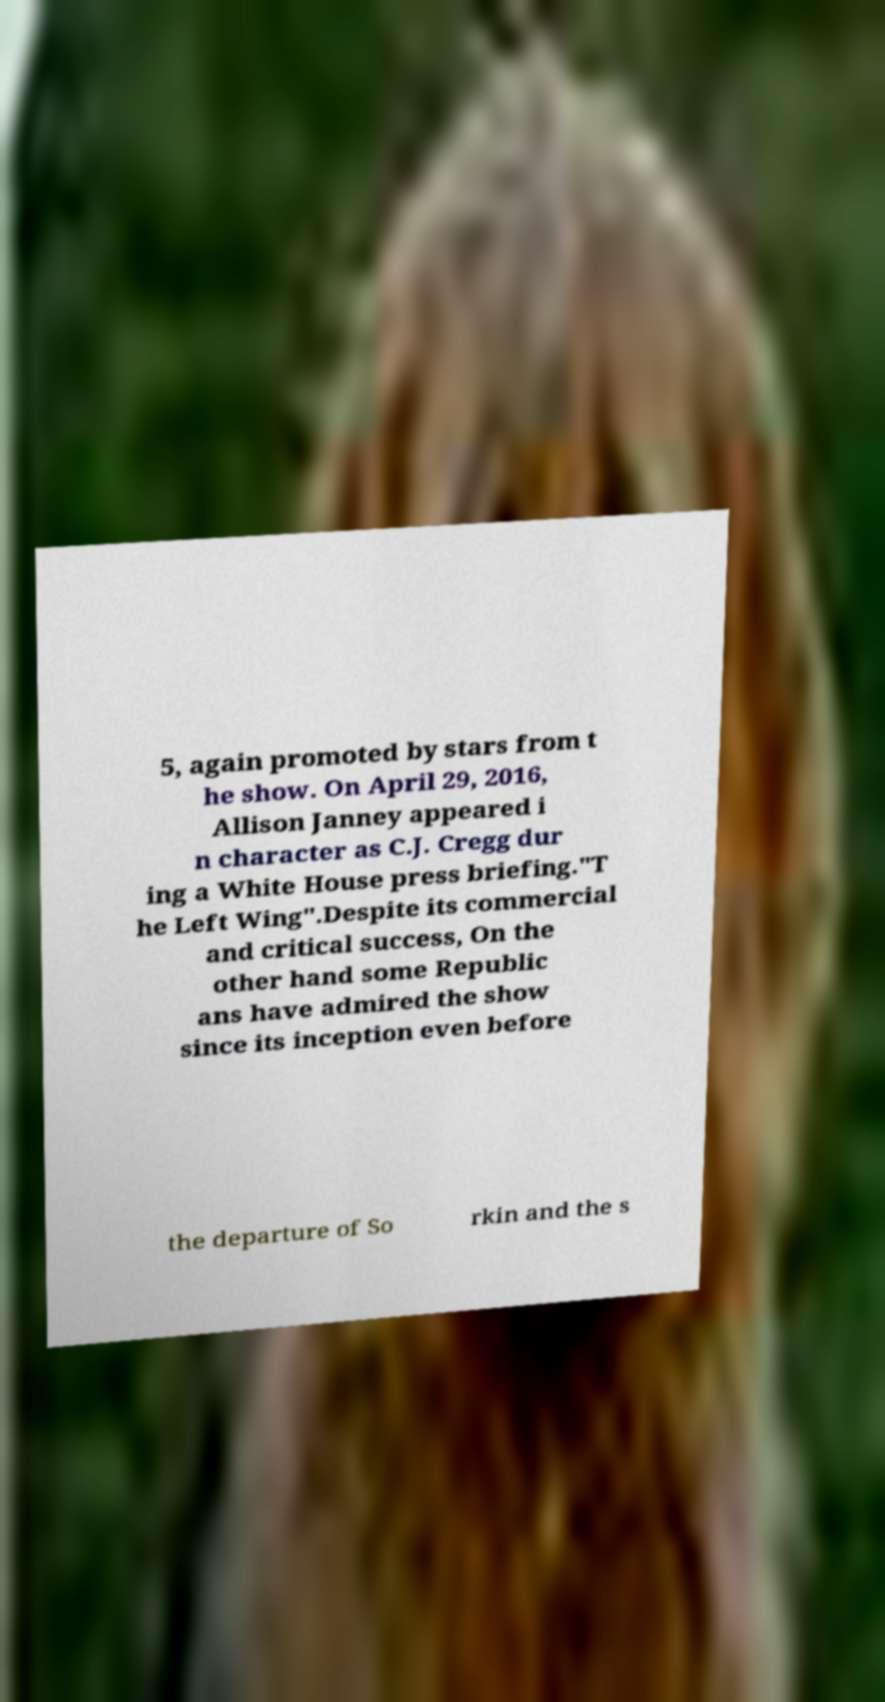I need the written content from this picture converted into text. Can you do that? 5, again promoted by stars from t he show. On April 29, 2016, Allison Janney appeared i n character as C.J. Cregg dur ing a White House press briefing."T he Left Wing".Despite its commercial and critical success, On the other hand some Republic ans have admired the show since its inception even before the departure of So rkin and the s 